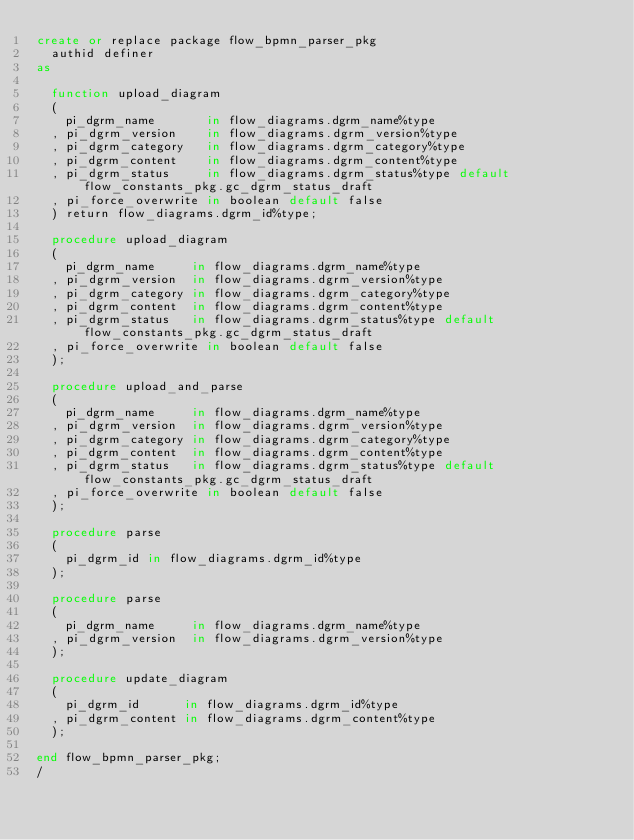Convert code to text. <code><loc_0><loc_0><loc_500><loc_500><_SQL_>create or replace package flow_bpmn_parser_pkg
  authid definer
as

  function upload_diagram
  (
    pi_dgrm_name       in flow_diagrams.dgrm_name%type
  , pi_dgrm_version    in flow_diagrams.dgrm_version%type
  , pi_dgrm_category   in flow_diagrams.dgrm_category%type
  , pi_dgrm_content    in flow_diagrams.dgrm_content%type
  , pi_dgrm_status     in flow_diagrams.dgrm_status%type default flow_constants_pkg.gc_dgrm_status_draft
  , pi_force_overwrite in boolean default false
  ) return flow_diagrams.dgrm_id%type;

  procedure upload_diagram
  (
    pi_dgrm_name     in flow_diagrams.dgrm_name%type
  , pi_dgrm_version  in flow_diagrams.dgrm_version%type
  , pi_dgrm_category in flow_diagrams.dgrm_category%type
  , pi_dgrm_content  in flow_diagrams.dgrm_content%type
  , pi_dgrm_status   in flow_diagrams.dgrm_status%type default flow_constants_pkg.gc_dgrm_status_draft
  , pi_force_overwrite in boolean default false
  );

  procedure upload_and_parse
  (
    pi_dgrm_name     in flow_diagrams.dgrm_name%type
  , pi_dgrm_version  in flow_diagrams.dgrm_version%type
  , pi_dgrm_category in flow_diagrams.dgrm_category%type
  , pi_dgrm_content  in flow_diagrams.dgrm_content%type
  , pi_dgrm_status   in flow_diagrams.dgrm_status%type default flow_constants_pkg.gc_dgrm_status_draft
  , pi_force_overwrite in boolean default false
  );

  procedure parse
  (
    pi_dgrm_id in flow_diagrams.dgrm_id%type
  );

  procedure parse
  (
    pi_dgrm_name     in flow_diagrams.dgrm_name%type
  , pi_dgrm_version  in flow_diagrams.dgrm_version%type
  );

  procedure update_diagram
  (
    pi_dgrm_id      in flow_diagrams.dgrm_id%type
  , pi_dgrm_content in flow_diagrams.dgrm_content%type
  );

end flow_bpmn_parser_pkg;
/
</code> 